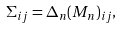<formula> <loc_0><loc_0><loc_500><loc_500>\Sigma _ { i j } = \Delta _ { n } ( M _ { n } ) _ { i j } ,</formula> 